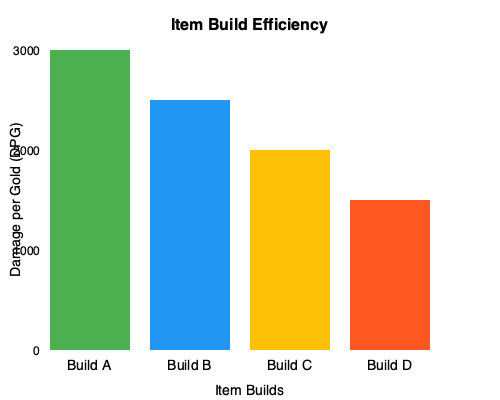As a carry player, you're comparing different item builds for cost-effectiveness. The bar chart shows the Damage per Gold (DPG) efficiency of four different builds. If Build A costs 3000 gold and has a DPG of 1.0, which build is the most cost-effective, and what is its approximate DPG? To determine the most cost-effective build and its DPG, we need to analyze the information given in the bar chart:

1. We're told that Build A costs 3000 gold and has a DPG of 1.0.
2. The y-axis represents DPG, with Build A's bar reaching the 3000 mark.
3. We can use Build A as a reference to estimate the DPG of other builds.

Let's compare the heights of the bars:

- Build A: Reaches 3000 (given DPG = 1.0)
- Build B: Reaches about 2500 (5/6 of Build A's height)
- Build C: Reaches about 2000 (2/3 of Build A's height)
- Build D: Reaches about 1500 (1/2 of Build A's height)

To calculate the approximate DPG for each build:

- Build B: $\frac{5}{6} \times 1.0 \approx 0.83$
- Build C: $\frac{2}{3} \times 1.0 \approx 0.67$
- Build D: $\frac{1}{2} \times 1.0 = 0.5$

Build A has the highest bar, indicating it has the highest DPG value of 1.0. Therefore, Build A is the most cost-effective build with a DPG of approximately 1.0.
Answer: Build A, DPG ≈ 1.0 